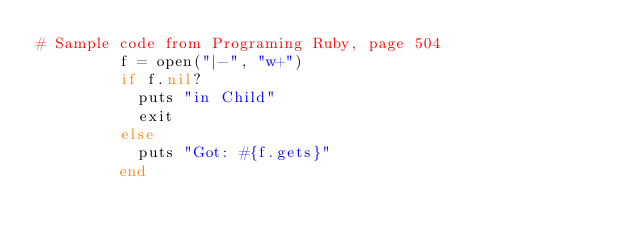Convert code to text. <code><loc_0><loc_0><loc_500><loc_500><_Ruby_># Sample code from Programing Ruby, page 504
         f = open("|-", "w+")
         if f.nil?
           puts "in Child"
           exit
         else
           puts "Got: #{f.gets}"
         end
</code> 